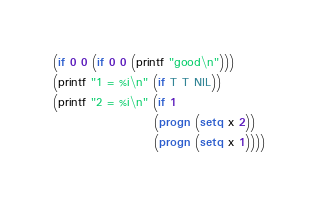<code> <loc_0><loc_0><loc_500><loc_500><_Lisp_>(if 0 0 (if 0 0 (printf "good\n")))
(printf "1 = %i\n" (if T T NIL))
(printf "2 = %i\n" (if 1
                     (progn (setq x 2))
                     (progn (setq x 1))))
</code> 